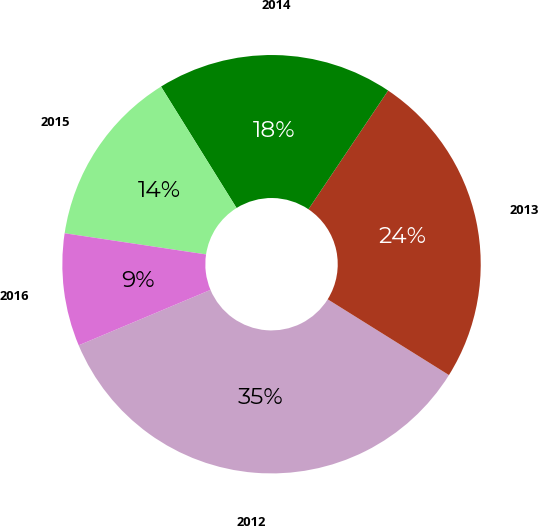Convert chart. <chart><loc_0><loc_0><loc_500><loc_500><pie_chart><fcel>2012<fcel>2013<fcel>2014<fcel>2015<fcel>2016<nl><fcel>34.78%<fcel>24.48%<fcel>18.27%<fcel>13.78%<fcel>8.7%<nl></chart> 